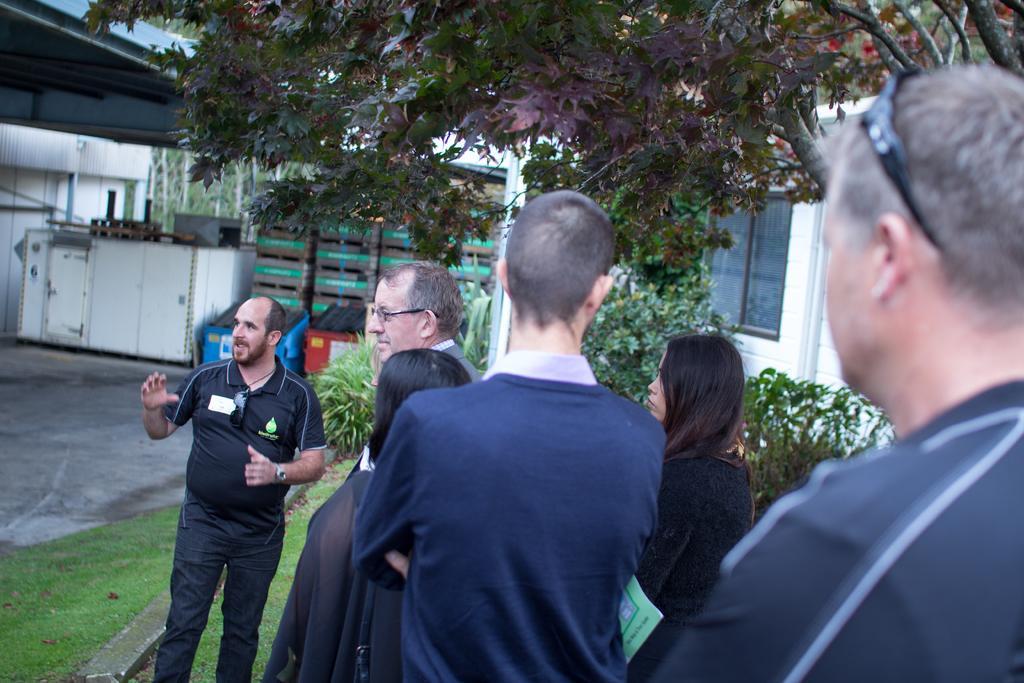Could you give a brief overview of what you see in this image? In this picture we can see some people standing here, at the bottom there is grass, we can see a tree in the background, on the right side there is a wall, we can see a window here. 